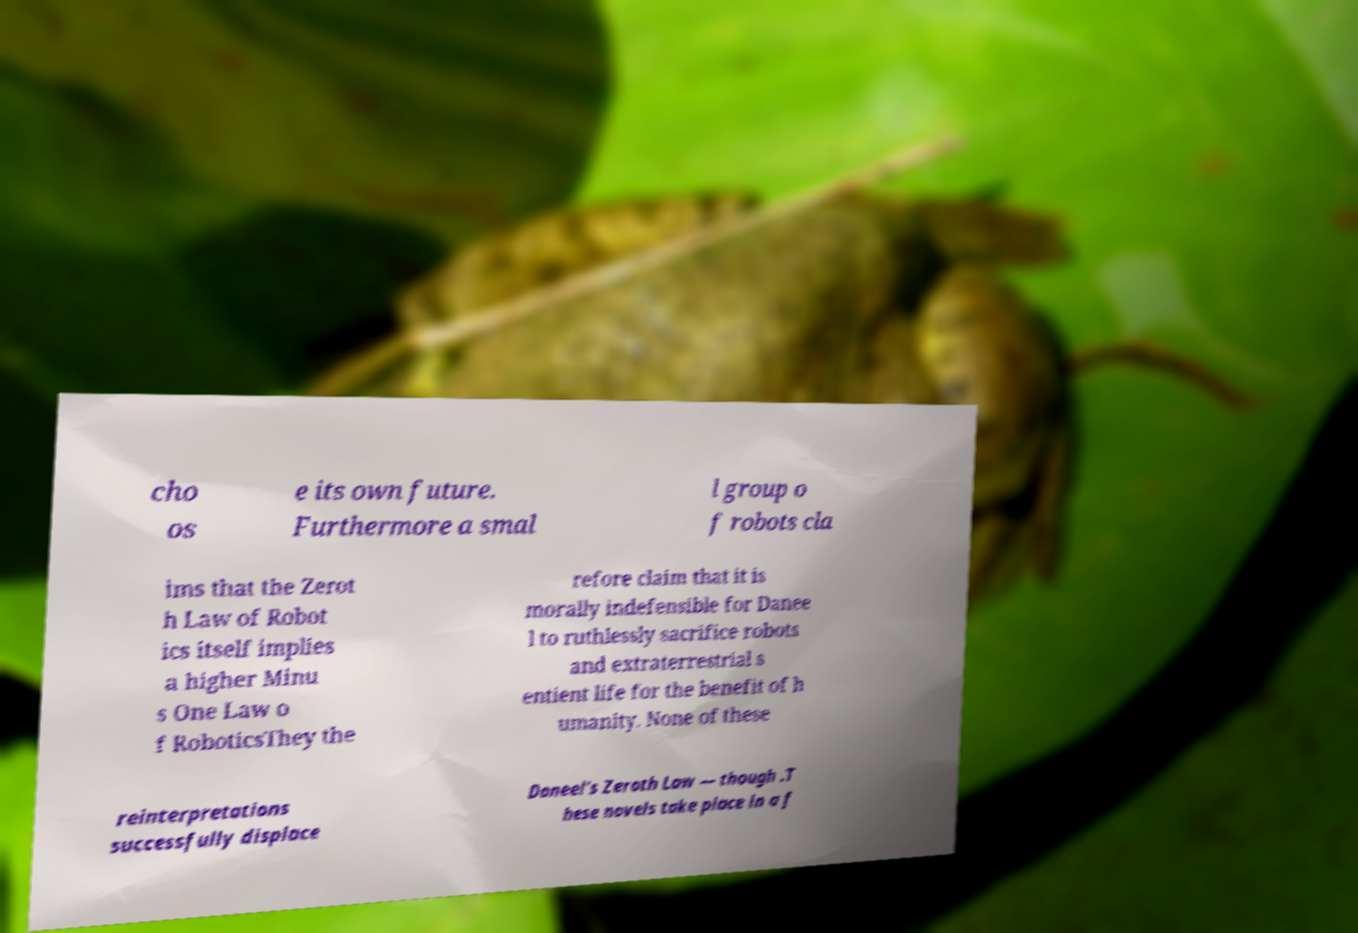Could you assist in decoding the text presented in this image and type it out clearly? cho os e its own future. Furthermore a smal l group o f robots cla ims that the Zerot h Law of Robot ics itself implies a higher Minu s One Law o f RoboticsThey the refore claim that it is morally indefensible for Danee l to ruthlessly sacrifice robots and extraterrestrial s entient life for the benefit of h umanity. None of these reinterpretations successfully displace Daneel's Zeroth Law — though .T hese novels take place in a f 